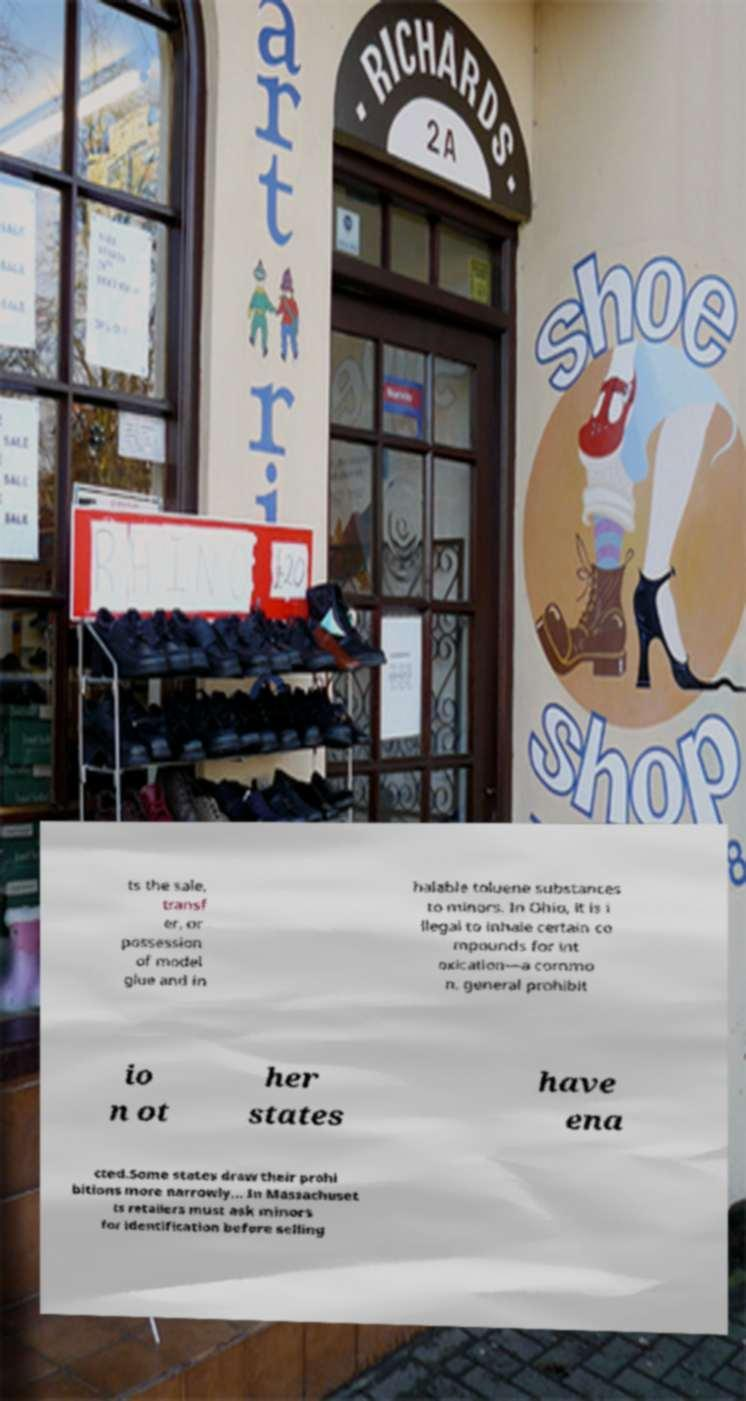There's text embedded in this image that I need extracted. Can you transcribe it verbatim? ts the sale, transf er, or possession of model glue and in halable toluene substances to minors. In Ohio, it is i llegal to inhale certain co mpounds for int oxication—a commo n, general prohibit io n ot her states have ena cted.Some states draw their prohi bitions more narrowly... In Massachuset ts retailers must ask minors for identification before selling 